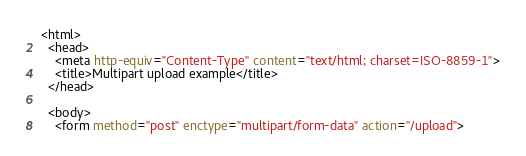Convert code to text. <code><loc_0><loc_0><loc_500><loc_500><_HTML_><html>
  <head>
    <meta http-equiv="Content-Type" content="text/html; charset=ISO-8859-1">
    <title>Multipart upload example</title>
  </head>

  <body>
    <form method="post" enctype="multipart/form-data" action="/upload"></code> 